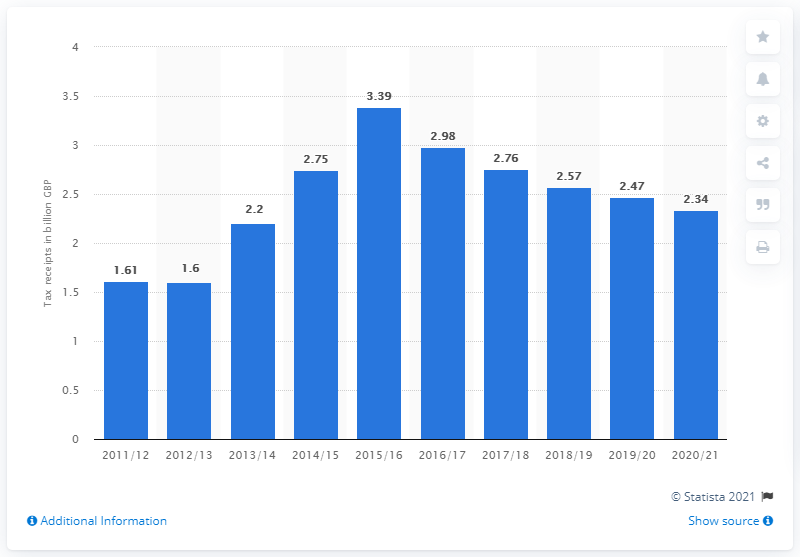Mention a couple of crucial points in this snapshot. In 2017/18, the amount of tax receipts from bank levies was 2.57. The amount of tax receipts from bank levies in British pounds in 2020/21 was 2.34. 